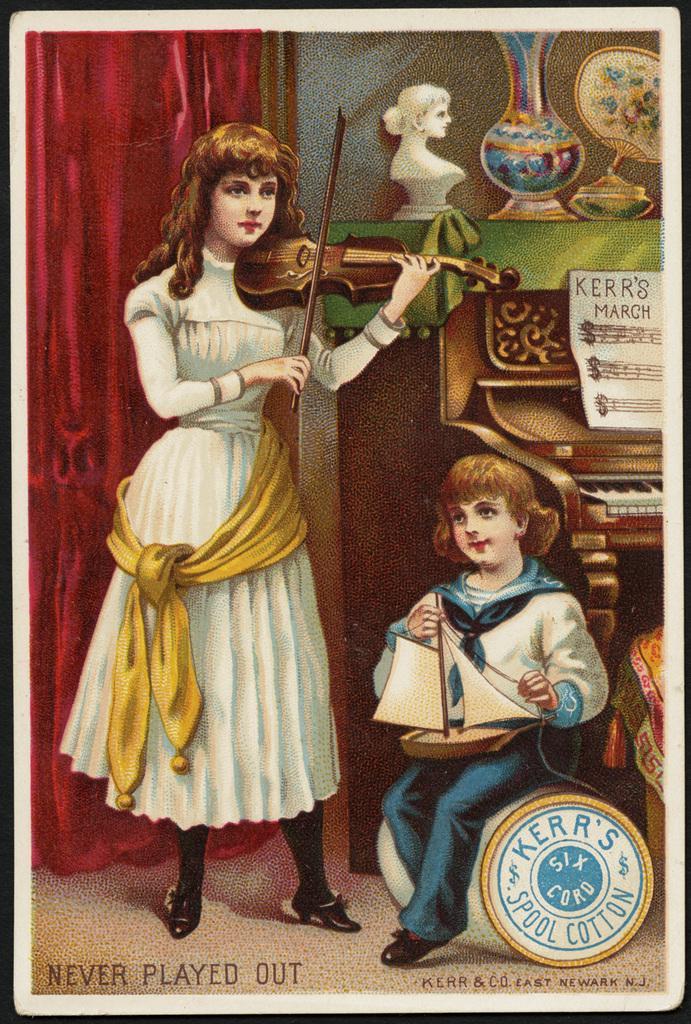Describe this image in one or two sentences. In this image it looks like it is a painting. In the painting there is a girl in the middle who is playing the violin. Beside her there is a girl who is sitting by holding the ship. On the right side there is a keyboard. On the right side top corner there is a flower vase,sculpture and a lamp. On the left side there is a curtain in the background. 